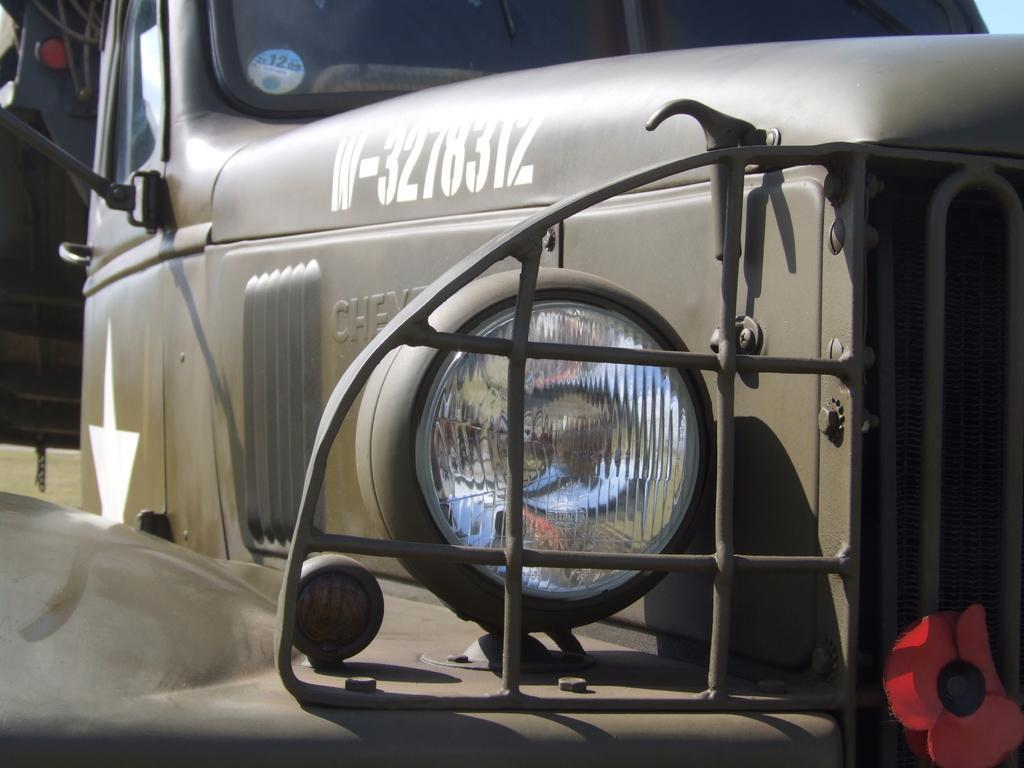Can you describe this image briefly? In this picture, we can see a vehicle. In the middle of the image, we can see a headlight of a vehicle. On the right corner of the image, we can see a flower on the vehicle. 